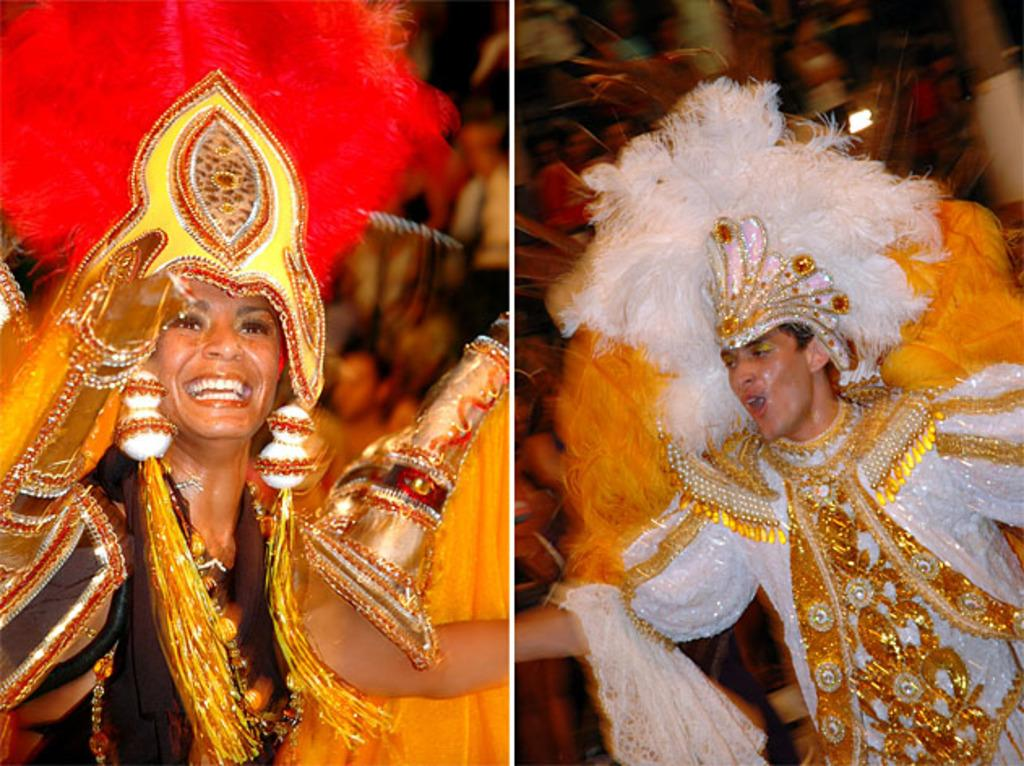What is the composition of the image? The image is a collage of multiple images. Can you describe the person on the right side of the collage? There is a person wearing a white dress on the right side of the collage. What is the woman on the left side of the collage doing? There is a woman standing on the left side of the collage. What expression does the woman have? The woman is smiling. What type of tax is being discussed in the image? There is no discussion of tax in the image; it is a collage of multiple images featuring people. Can you tell me how many stalks of celery are visible in the image? There is no celery present in the image. 